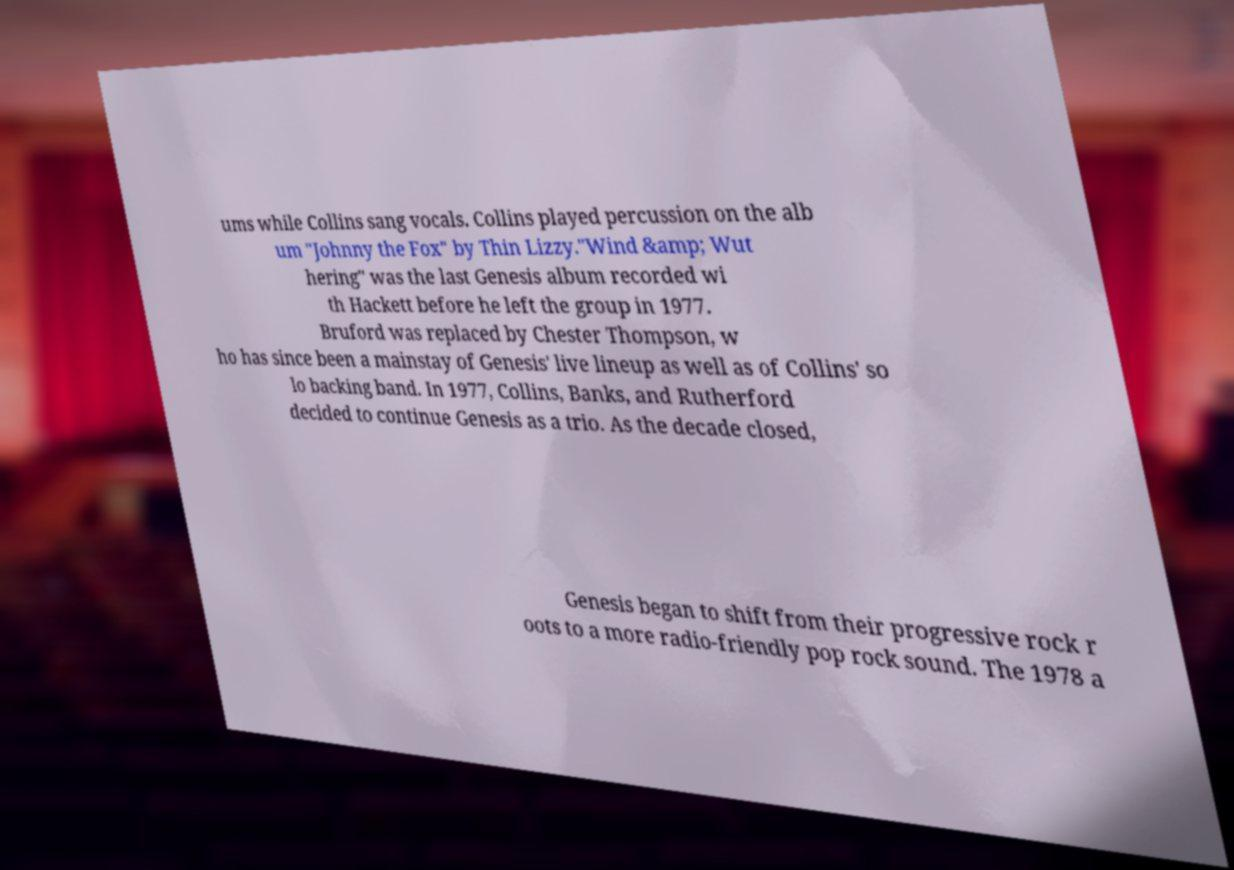Can you accurately transcribe the text from the provided image for me? ums while Collins sang vocals. Collins played percussion on the alb um "Johnny the Fox" by Thin Lizzy."Wind &amp; Wut hering" was the last Genesis album recorded wi th Hackett before he left the group in 1977. Bruford was replaced by Chester Thompson, w ho has since been a mainstay of Genesis' live lineup as well as of Collins' so lo backing band. In 1977, Collins, Banks, and Rutherford decided to continue Genesis as a trio. As the decade closed, Genesis began to shift from their progressive rock r oots to a more radio-friendly pop rock sound. The 1978 a 